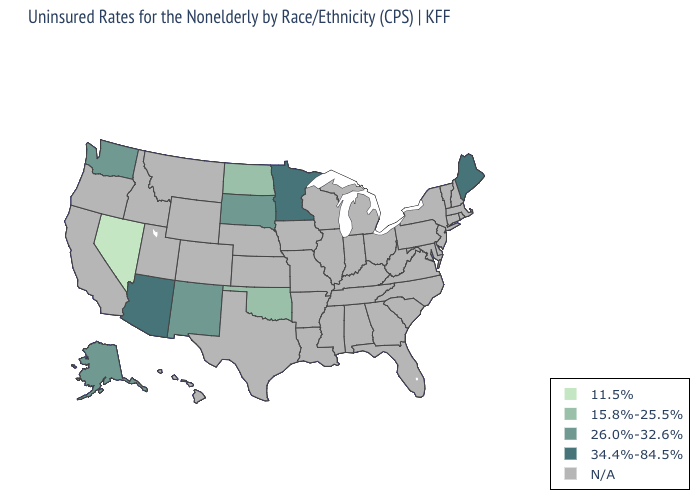Name the states that have a value in the range 26.0%-32.6%?
Write a very short answer. Alaska, New Mexico, South Dakota, Washington. Name the states that have a value in the range 11.5%?
Answer briefly. Nevada. Does the map have missing data?
Be succinct. Yes. Name the states that have a value in the range 26.0%-32.6%?
Short answer required. Alaska, New Mexico, South Dakota, Washington. What is the value of Vermont?
Concise answer only. N/A. Which states have the lowest value in the Northeast?
Be succinct. Maine. Which states have the lowest value in the USA?
Concise answer only. Nevada. What is the lowest value in the South?
Concise answer only. 15.8%-25.5%. What is the lowest value in the USA?
Keep it brief. 11.5%. What is the value of Washington?
Answer briefly. 26.0%-32.6%. Does Maine have the highest value in the USA?
Answer briefly. Yes. Does Minnesota have the highest value in the USA?
Answer briefly. Yes. Which states have the lowest value in the MidWest?
Write a very short answer. North Dakota. 